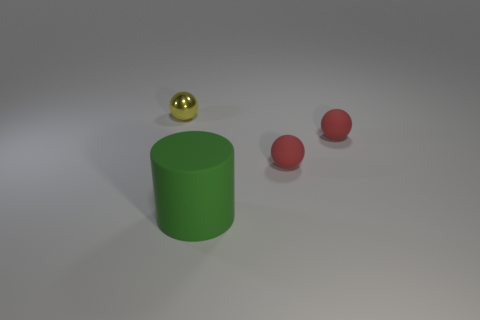Add 2 small blue metallic blocks. How many objects exist? 6 How many red spheres must be subtracted to get 1 red spheres? 1 Subtract 1 cylinders. How many cylinders are left? 0 Subtract all purple balls. Subtract all red cylinders. How many balls are left? 3 Subtract all cyan blocks. How many yellow spheres are left? 1 Subtract all green cylinders. Subtract all cylinders. How many objects are left? 2 Add 4 rubber cylinders. How many rubber cylinders are left? 5 Add 3 blue metal objects. How many blue metal objects exist? 3 Subtract all yellow balls. How many balls are left? 2 Subtract all yellow metallic balls. How many balls are left? 2 